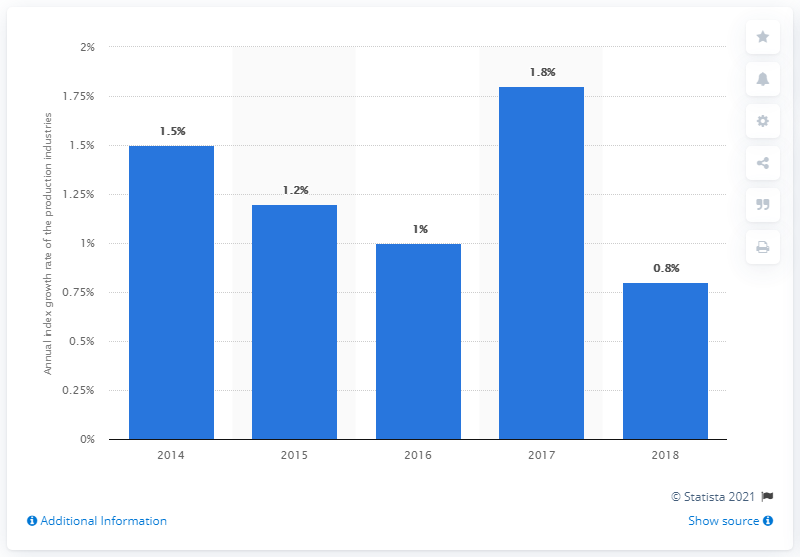Point out several critical features in this image. The production industries reached a peak index value in the year 2017. 